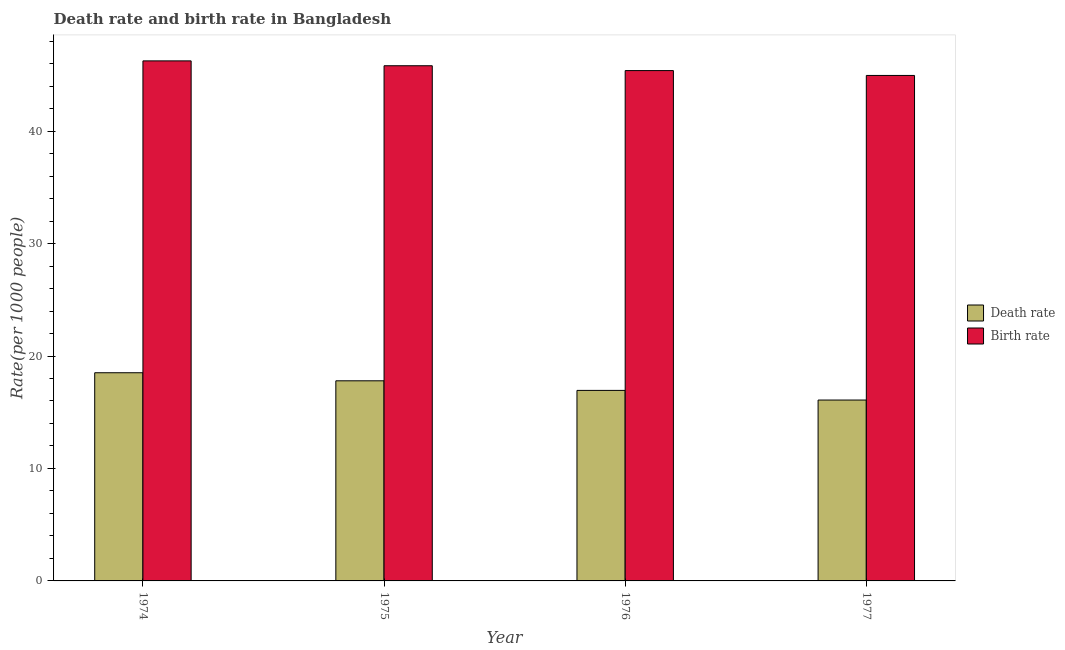How many groups of bars are there?
Provide a short and direct response. 4. How many bars are there on the 4th tick from the left?
Ensure brevity in your answer.  2. How many bars are there on the 1st tick from the right?
Provide a short and direct response. 2. What is the label of the 1st group of bars from the left?
Keep it short and to the point. 1974. What is the birth rate in 1976?
Make the answer very short. 45.38. Across all years, what is the maximum birth rate?
Give a very brief answer. 46.25. Across all years, what is the minimum birth rate?
Provide a succinct answer. 44.95. In which year was the death rate maximum?
Your answer should be compact. 1974. What is the total death rate in the graph?
Provide a succinct answer. 69.34. What is the difference between the death rate in 1975 and that in 1977?
Your response must be concise. 1.71. What is the difference between the birth rate in 1976 and the death rate in 1975?
Give a very brief answer. -0.43. What is the average death rate per year?
Provide a short and direct response. 17.33. In how many years, is the birth rate greater than 46?
Ensure brevity in your answer.  1. What is the ratio of the death rate in 1975 to that in 1976?
Provide a succinct answer. 1.05. Is the birth rate in 1976 less than that in 1977?
Keep it short and to the point. No. Is the difference between the birth rate in 1974 and 1976 greater than the difference between the death rate in 1974 and 1976?
Your answer should be compact. No. What is the difference between the highest and the second highest birth rate?
Give a very brief answer. 0.43. What is the difference between the highest and the lowest death rate?
Your response must be concise. 2.43. In how many years, is the death rate greater than the average death rate taken over all years?
Provide a short and direct response. 2. What does the 2nd bar from the left in 1976 represents?
Ensure brevity in your answer.  Birth rate. What does the 1st bar from the right in 1977 represents?
Make the answer very short. Birth rate. What is the difference between two consecutive major ticks on the Y-axis?
Offer a terse response. 10. Does the graph contain any zero values?
Offer a very short reply. No. How many legend labels are there?
Make the answer very short. 2. What is the title of the graph?
Ensure brevity in your answer.  Death rate and birth rate in Bangladesh. What is the label or title of the X-axis?
Make the answer very short. Year. What is the label or title of the Y-axis?
Make the answer very short. Rate(per 1000 people). What is the Rate(per 1000 people) in Death rate in 1974?
Make the answer very short. 18.51. What is the Rate(per 1000 people) in Birth rate in 1974?
Keep it short and to the point. 46.25. What is the Rate(per 1000 people) in Death rate in 1975?
Your answer should be very brief. 17.8. What is the Rate(per 1000 people) of Birth rate in 1975?
Offer a terse response. 45.81. What is the Rate(per 1000 people) in Death rate in 1976?
Your answer should be compact. 16.94. What is the Rate(per 1000 people) in Birth rate in 1976?
Your response must be concise. 45.38. What is the Rate(per 1000 people) in Death rate in 1977?
Offer a very short reply. 16.09. What is the Rate(per 1000 people) in Birth rate in 1977?
Your response must be concise. 44.95. Across all years, what is the maximum Rate(per 1000 people) in Death rate?
Offer a very short reply. 18.51. Across all years, what is the maximum Rate(per 1000 people) of Birth rate?
Your answer should be very brief. 46.25. Across all years, what is the minimum Rate(per 1000 people) in Death rate?
Offer a very short reply. 16.09. Across all years, what is the minimum Rate(per 1000 people) in Birth rate?
Make the answer very short. 44.95. What is the total Rate(per 1000 people) of Death rate in the graph?
Your response must be concise. 69.34. What is the total Rate(per 1000 people) of Birth rate in the graph?
Offer a terse response. 182.39. What is the difference between the Rate(per 1000 people) in Death rate in 1974 and that in 1975?
Your answer should be compact. 0.72. What is the difference between the Rate(per 1000 people) of Birth rate in 1974 and that in 1975?
Offer a terse response. 0.43. What is the difference between the Rate(per 1000 people) in Death rate in 1974 and that in 1976?
Ensure brevity in your answer.  1.57. What is the difference between the Rate(per 1000 people) of Birth rate in 1974 and that in 1976?
Make the answer very short. 0.86. What is the difference between the Rate(per 1000 people) of Death rate in 1974 and that in 1977?
Give a very brief answer. 2.43. What is the difference between the Rate(per 1000 people) in Birth rate in 1974 and that in 1977?
Offer a terse response. 1.3. What is the difference between the Rate(per 1000 people) in Death rate in 1975 and that in 1976?
Provide a succinct answer. 0.85. What is the difference between the Rate(per 1000 people) in Birth rate in 1975 and that in 1976?
Your answer should be very brief. 0.43. What is the difference between the Rate(per 1000 people) of Death rate in 1975 and that in 1977?
Offer a very short reply. 1.71. What is the difference between the Rate(per 1000 people) of Birth rate in 1975 and that in 1977?
Offer a terse response. 0.86. What is the difference between the Rate(per 1000 people) in Death rate in 1976 and that in 1977?
Your answer should be compact. 0.86. What is the difference between the Rate(per 1000 people) of Birth rate in 1976 and that in 1977?
Offer a very short reply. 0.43. What is the difference between the Rate(per 1000 people) in Death rate in 1974 and the Rate(per 1000 people) in Birth rate in 1975?
Your answer should be very brief. -27.3. What is the difference between the Rate(per 1000 people) of Death rate in 1974 and the Rate(per 1000 people) of Birth rate in 1976?
Your response must be concise. -26.87. What is the difference between the Rate(per 1000 people) in Death rate in 1974 and the Rate(per 1000 people) in Birth rate in 1977?
Ensure brevity in your answer.  -26.44. What is the difference between the Rate(per 1000 people) of Death rate in 1975 and the Rate(per 1000 people) of Birth rate in 1976?
Offer a terse response. -27.59. What is the difference between the Rate(per 1000 people) of Death rate in 1975 and the Rate(per 1000 people) of Birth rate in 1977?
Offer a terse response. -27.15. What is the difference between the Rate(per 1000 people) in Death rate in 1976 and the Rate(per 1000 people) in Birth rate in 1977?
Your response must be concise. -28.01. What is the average Rate(per 1000 people) in Death rate per year?
Your answer should be compact. 17.33. What is the average Rate(per 1000 people) in Birth rate per year?
Your response must be concise. 45.6. In the year 1974, what is the difference between the Rate(per 1000 people) of Death rate and Rate(per 1000 people) of Birth rate?
Provide a short and direct response. -27.73. In the year 1975, what is the difference between the Rate(per 1000 people) in Death rate and Rate(per 1000 people) in Birth rate?
Offer a very short reply. -28.02. In the year 1976, what is the difference between the Rate(per 1000 people) of Death rate and Rate(per 1000 people) of Birth rate?
Provide a succinct answer. -28.44. In the year 1977, what is the difference between the Rate(per 1000 people) of Death rate and Rate(per 1000 people) of Birth rate?
Your answer should be compact. -28.86. What is the ratio of the Rate(per 1000 people) of Death rate in 1974 to that in 1975?
Your answer should be compact. 1.04. What is the ratio of the Rate(per 1000 people) of Birth rate in 1974 to that in 1975?
Keep it short and to the point. 1.01. What is the ratio of the Rate(per 1000 people) of Death rate in 1974 to that in 1976?
Give a very brief answer. 1.09. What is the ratio of the Rate(per 1000 people) of Death rate in 1974 to that in 1977?
Your answer should be very brief. 1.15. What is the ratio of the Rate(per 1000 people) of Birth rate in 1974 to that in 1977?
Your answer should be compact. 1.03. What is the ratio of the Rate(per 1000 people) of Death rate in 1975 to that in 1976?
Your answer should be compact. 1.05. What is the ratio of the Rate(per 1000 people) in Birth rate in 1975 to that in 1976?
Provide a succinct answer. 1.01. What is the ratio of the Rate(per 1000 people) of Death rate in 1975 to that in 1977?
Make the answer very short. 1.11. What is the ratio of the Rate(per 1000 people) in Birth rate in 1975 to that in 1977?
Your answer should be compact. 1.02. What is the ratio of the Rate(per 1000 people) in Death rate in 1976 to that in 1977?
Offer a very short reply. 1.05. What is the ratio of the Rate(per 1000 people) of Birth rate in 1976 to that in 1977?
Provide a succinct answer. 1.01. What is the difference between the highest and the second highest Rate(per 1000 people) of Death rate?
Your response must be concise. 0.72. What is the difference between the highest and the second highest Rate(per 1000 people) in Birth rate?
Offer a terse response. 0.43. What is the difference between the highest and the lowest Rate(per 1000 people) of Death rate?
Keep it short and to the point. 2.43. What is the difference between the highest and the lowest Rate(per 1000 people) of Birth rate?
Ensure brevity in your answer.  1.3. 